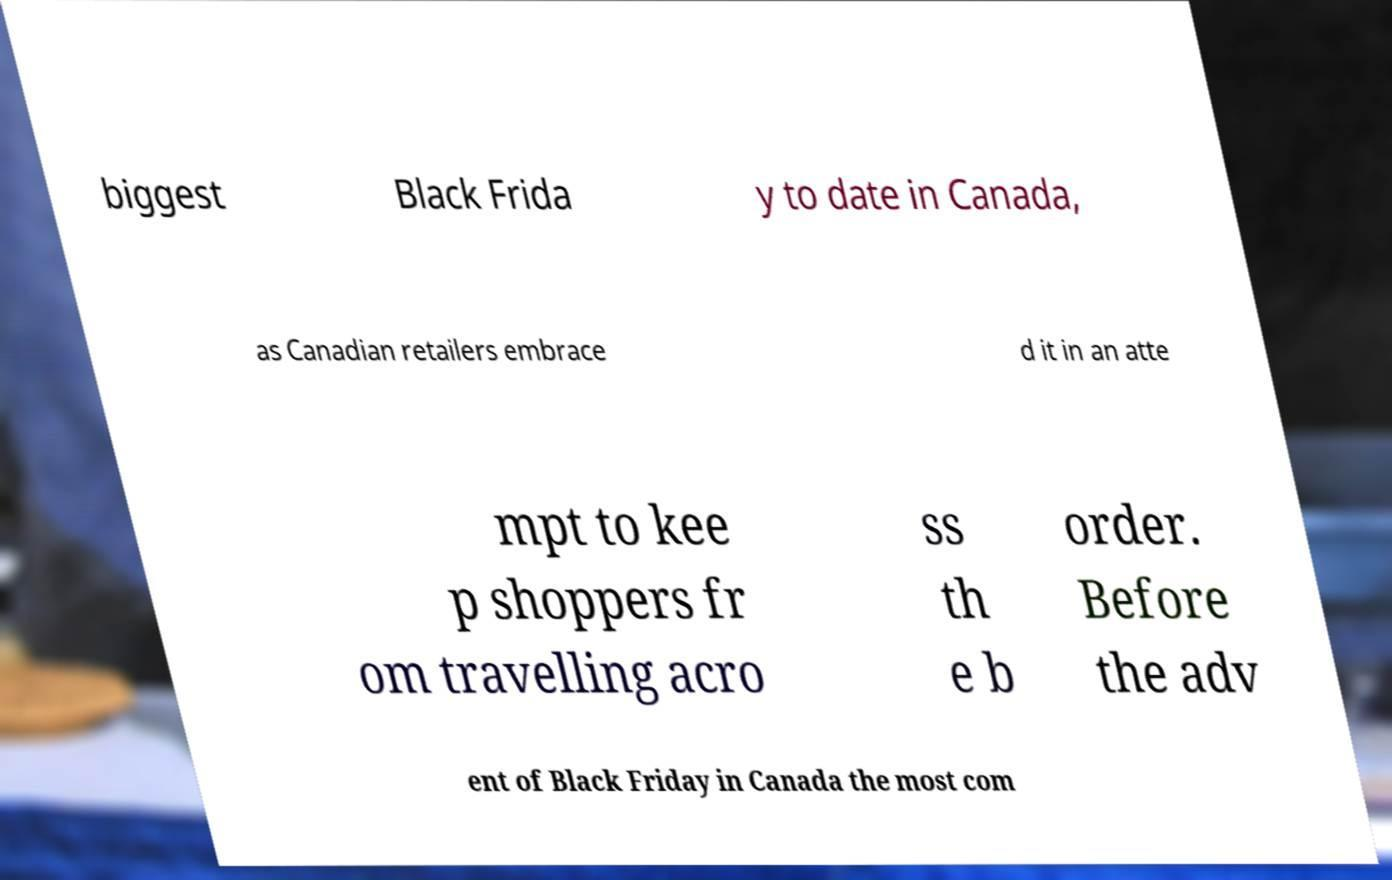Can you accurately transcribe the text from the provided image for me? biggest Black Frida y to date in Canada, as Canadian retailers embrace d it in an atte mpt to kee p shoppers fr om travelling acro ss th e b order. Before the adv ent of Black Friday in Canada the most com 